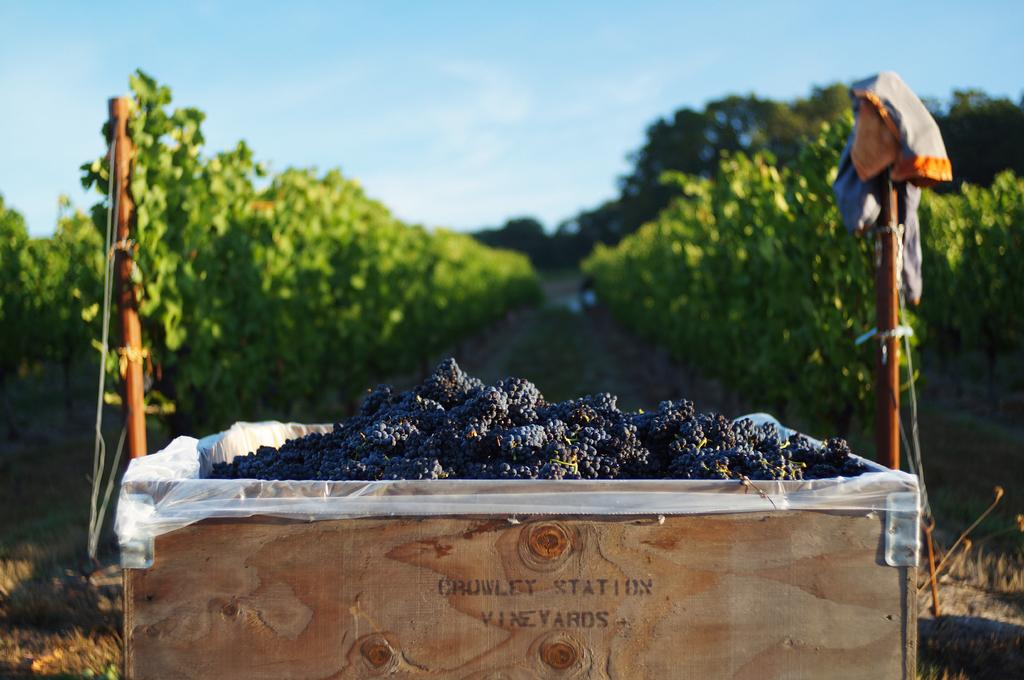What is contained in the wooden box in the image? There are many grapes in a wooden box in the image. What additional information is provided on the wooden box? There is text written on the wooden box. What can be seen behind the wooden box? There are two rods behind the wooden box. What type of natural environment is visible in the background of the image? There are trees and plants in the background of the image. Can you hear someone coughing in the image? There is no auditory information provided in the image, so it is impossible to determine if someone is coughing. What type of pen is being used to write on the wooden box? There is no pen visible in the image, and the text on the wooden box is not mentioned as being written in the image. 